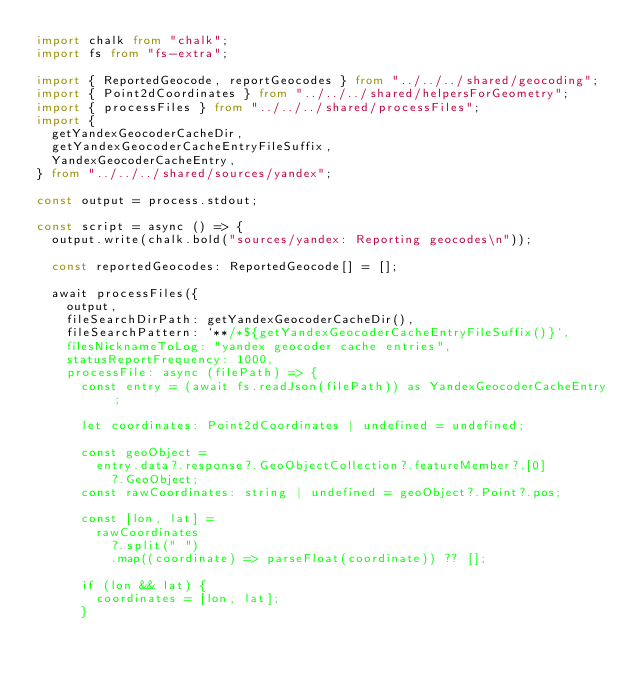<code> <loc_0><loc_0><loc_500><loc_500><_TypeScript_>import chalk from "chalk";
import fs from "fs-extra";

import { ReportedGeocode, reportGeocodes } from "../../../shared/geocoding";
import { Point2dCoordinates } from "../../../shared/helpersForGeometry";
import { processFiles } from "../../../shared/processFiles";
import {
  getYandexGeocoderCacheDir,
  getYandexGeocoderCacheEntryFileSuffix,
  YandexGeocoderCacheEntry,
} from "../../../shared/sources/yandex";

const output = process.stdout;

const script = async () => {
  output.write(chalk.bold("sources/yandex: Reporting geocodes\n"));

  const reportedGeocodes: ReportedGeocode[] = [];

  await processFiles({
    output,
    fileSearchDirPath: getYandexGeocoderCacheDir(),
    fileSearchPattern: `**/*${getYandexGeocoderCacheEntryFileSuffix()}`,
    filesNicknameToLog: "yandex geocoder cache entries",
    statusReportFrequency: 1000,
    processFile: async (filePath) => {
      const entry = (await fs.readJson(filePath)) as YandexGeocoderCacheEntry;

      let coordinates: Point2dCoordinates | undefined = undefined;

      const geoObject =
        entry.data?.response?.GeoObjectCollection?.featureMember?.[0]
          ?.GeoObject;
      const rawCoordinates: string | undefined = geoObject?.Point?.pos;

      const [lon, lat] =
        rawCoordinates
          ?.split(" ")
          .map((coordinate) => parseFloat(coordinate)) ?? [];

      if (lon && lat) {
        coordinates = [lon, lat];
      }
</code> 